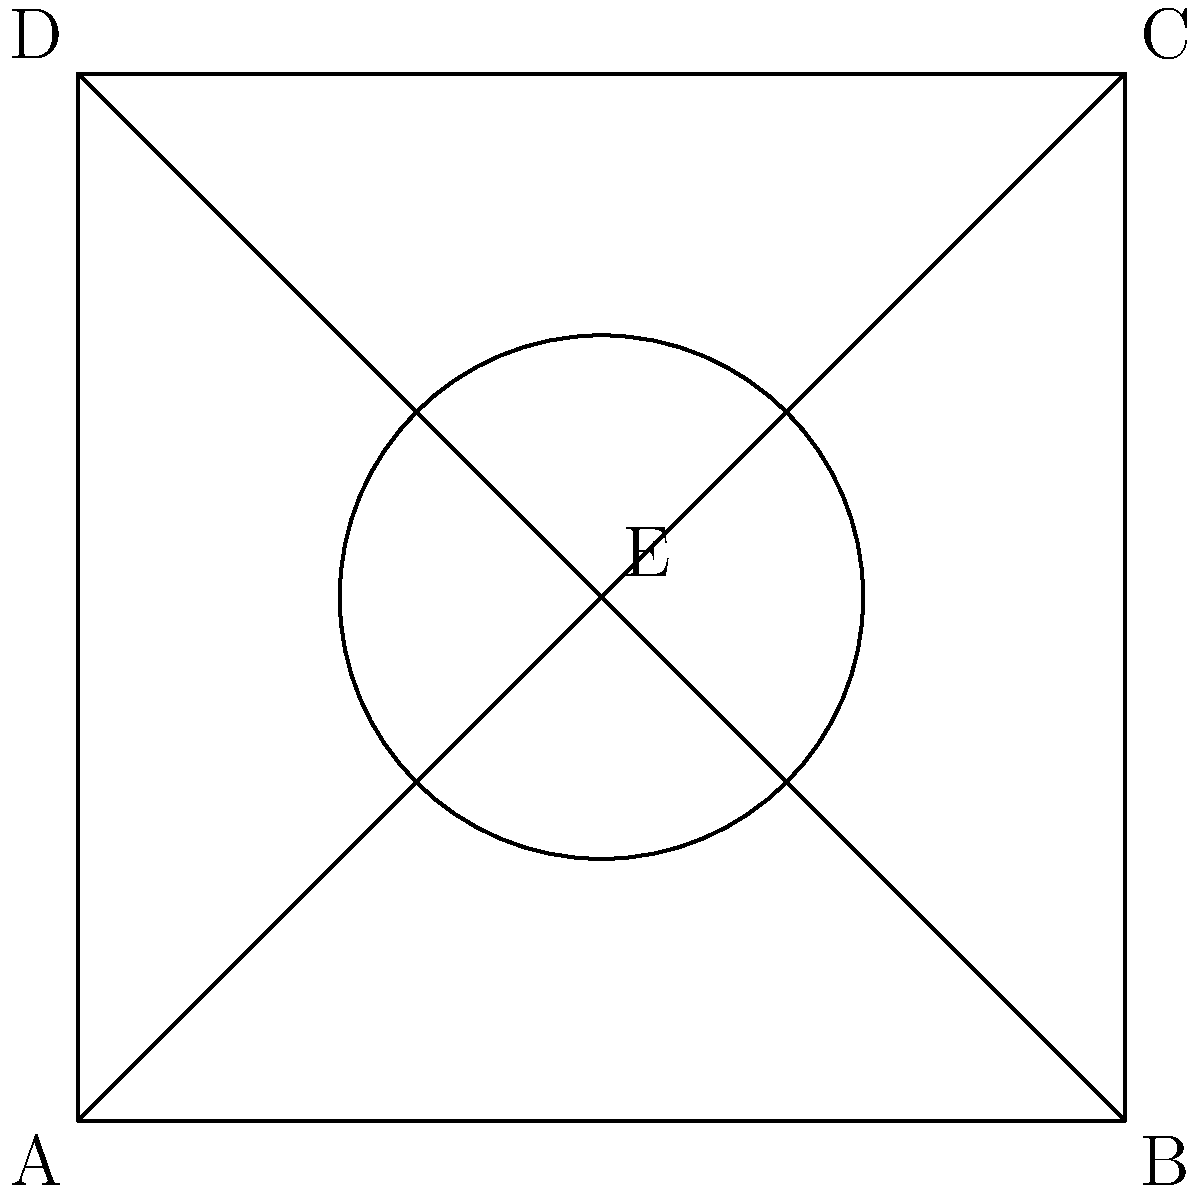Consider the architectural design of a traditional courtyard house from your home country, represented by the square ABCD with diagonals and a central circular feature. Determine the order of the symmetry group for this design and identify its isomorphism class. To solve this problem, we'll follow these steps:

1. Identify the symmetries:
   a) Rotational symmetries: 90°, 180°, 270°, and 360° (identity) around the center E.
   b) Reflectional symmetries: across AC, BD, and the vertical and horizontal lines through E.

2. Count the number of symmetries:
   - 4 rotations (including identity)
   - 4 reflections
   Total: 8 symmetries

3. Determine the order of the symmetry group:
   The order is equal to the total number of symmetries, which is 8.

4. Identify the isomorphism class:
   - The group has order 8
   - It contains both rotations and reflections
   - It has a 4-fold rotational symmetry

   These properties match the dihedral group of order 8, denoted as $D_4$ or $D_8$ (depending on the notation system).

The dihedral group $D_4$ is generated by a rotation $r$ of order 4 and a reflection $s$, satisfying the relations:
   $r^4 = e$, $s^2 = e$, $srs = r^{-1}$

where $e$ is the identity element.
Answer: Order: 8; Isomorphism class: $D_4$ 